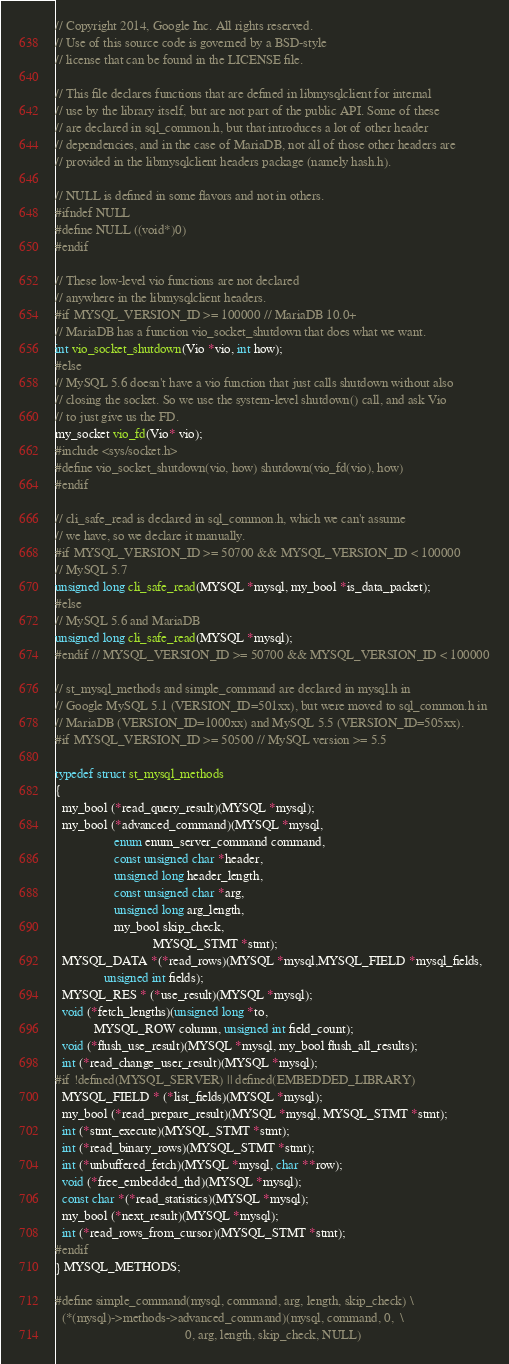Convert code to text. <code><loc_0><loc_0><loc_500><loc_500><_C_>// Copyright 2014, Google Inc. All rights reserved.
// Use of this source code is governed by a BSD-style
// license that can be found in the LICENSE file.

// This file declares functions that are defined in libmysqlclient for internal
// use by the library itself, but are not part of the public API. Some of these
// are declared in sql_common.h, but that introduces a lot of other header
// dependencies, and in the case of MariaDB, not all of those other headers are
// provided in the libmysqlclient headers package (namely hash.h).

// NULL is defined in some flavors and not in others.
#ifndef NULL
#define NULL ((void*)0)
#endif

// These low-level vio functions are not declared
// anywhere in the libmysqlclient headers.
#if MYSQL_VERSION_ID >= 100000 // MariaDB 10.0+
// MariaDB has a function vio_socket_shutdown that does what we want.
int vio_socket_shutdown(Vio *vio, int how);
#else
// MySQL 5.6 doesn't have a vio function that just calls shutdown without also
// closing the socket. So we use the system-level shutdown() call, and ask Vio
// to just give us the FD.
my_socket vio_fd(Vio* vio);
#include <sys/socket.h>
#define vio_socket_shutdown(vio, how) shutdown(vio_fd(vio), how)
#endif

// cli_safe_read is declared in sql_common.h, which we can't assume
// we have, so we declare it manually.
#if MYSQL_VERSION_ID >= 50700 && MYSQL_VERSION_ID < 100000
// MySQL 5.7
unsigned long cli_safe_read(MYSQL *mysql, my_bool *is_data_packet);
#else
// MySQL 5.6 and MariaDB
unsigned long cli_safe_read(MYSQL *mysql);
#endif // MYSQL_VERSION_ID >= 50700 && MYSQL_VERSION_ID < 100000

// st_mysql_methods and simple_command are declared in mysql.h in
// Google MySQL 5.1 (VERSION_ID=501xx), but were moved to sql_common.h in
// MariaDB (VERSION_ID=1000xx) and MySQL 5.5 (VERSION_ID=505xx).
#if MYSQL_VERSION_ID >= 50500 // MySQL version >= 5.5

typedef struct st_mysql_methods
{
  my_bool (*read_query_result)(MYSQL *mysql);
  my_bool (*advanced_command)(MYSQL *mysql,
                  enum enum_server_command command,
                  const unsigned char *header,
                  unsigned long header_length,
                  const unsigned char *arg,
                  unsigned long arg_length,
                  my_bool skip_check,
                              MYSQL_STMT *stmt);
  MYSQL_DATA *(*read_rows)(MYSQL *mysql,MYSQL_FIELD *mysql_fields,
               unsigned int fields);
  MYSQL_RES * (*use_result)(MYSQL *mysql);
  void (*fetch_lengths)(unsigned long *to,
            MYSQL_ROW column, unsigned int field_count);
  void (*flush_use_result)(MYSQL *mysql, my_bool flush_all_results);
  int (*read_change_user_result)(MYSQL *mysql);
#if !defined(MYSQL_SERVER) || defined(EMBEDDED_LIBRARY)
  MYSQL_FIELD * (*list_fields)(MYSQL *mysql);
  my_bool (*read_prepare_result)(MYSQL *mysql, MYSQL_STMT *stmt);
  int (*stmt_execute)(MYSQL_STMT *stmt);
  int (*read_binary_rows)(MYSQL_STMT *stmt);
  int (*unbuffered_fetch)(MYSQL *mysql, char **row);
  void (*free_embedded_thd)(MYSQL *mysql);
  const char *(*read_statistics)(MYSQL *mysql);
  my_bool (*next_result)(MYSQL *mysql);
  int (*read_rows_from_cursor)(MYSQL_STMT *stmt);
#endif
} MYSQL_METHODS;

#define simple_command(mysql, command, arg, length, skip_check) \
  (*(mysql)->methods->advanced_command)(mysql, command, 0,  \
                                        0, arg, length, skip_check, NULL)
</code> 